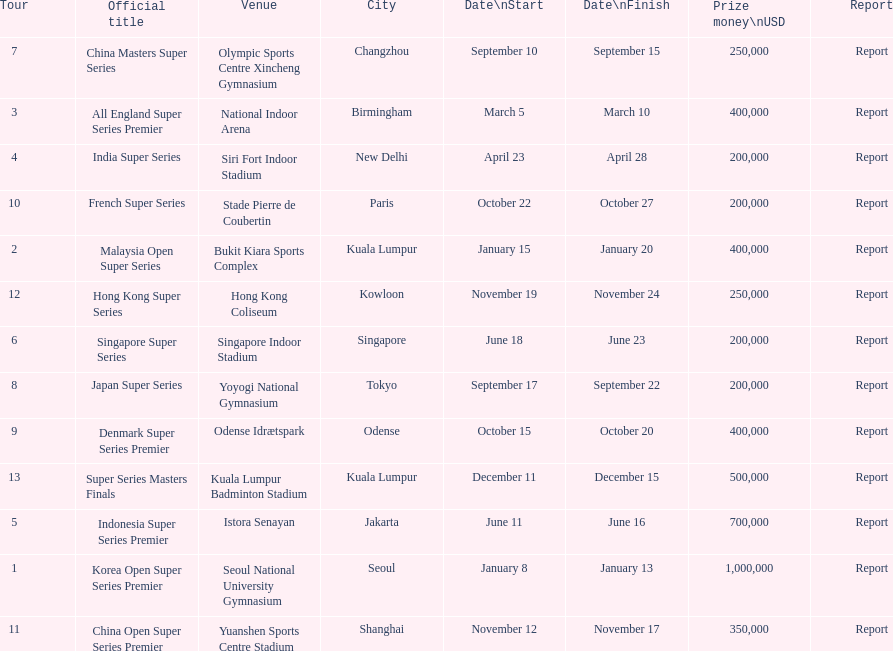Does the malaysia open super series pay more or less than french super series? More. 